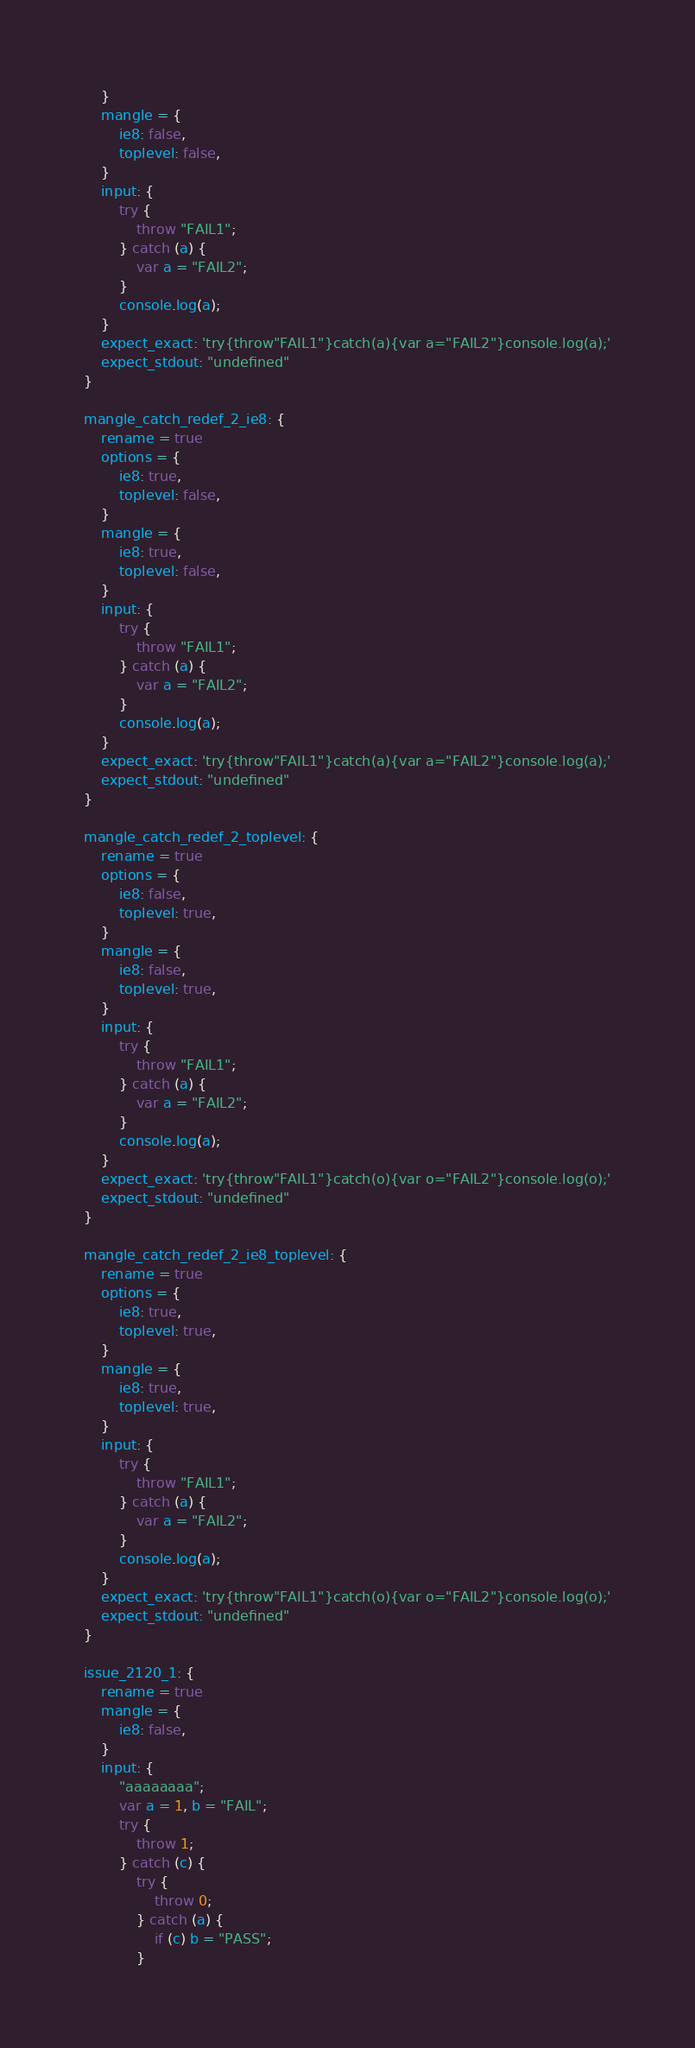Convert code to text. <code><loc_0><loc_0><loc_500><loc_500><_JavaScript_>    }
    mangle = {
        ie8: false,
        toplevel: false,
    }
    input: {
        try {
            throw "FAIL1";
        } catch (a) {
            var a = "FAIL2";
        }
        console.log(a);
    }
    expect_exact: 'try{throw"FAIL1"}catch(a){var a="FAIL2"}console.log(a);'
    expect_stdout: "undefined"
}

mangle_catch_redef_2_ie8: {
    rename = true
    options = {
        ie8: true,
        toplevel: false,
    }
    mangle = {
        ie8: true,
        toplevel: false,
    }
    input: {
        try {
            throw "FAIL1";
        } catch (a) {
            var a = "FAIL2";
        }
        console.log(a);
    }
    expect_exact: 'try{throw"FAIL1"}catch(a){var a="FAIL2"}console.log(a);'
    expect_stdout: "undefined"
}

mangle_catch_redef_2_toplevel: {
    rename = true
    options = {
        ie8: false,
        toplevel: true,
    }
    mangle = {
        ie8: false,
        toplevel: true,
    }
    input: {
        try {
            throw "FAIL1";
        } catch (a) {
            var a = "FAIL2";
        }
        console.log(a);
    }
    expect_exact: 'try{throw"FAIL1"}catch(o){var o="FAIL2"}console.log(o);'
    expect_stdout: "undefined"
}

mangle_catch_redef_2_ie8_toplevel: {
    rename = true
    options = {
        ie8: true,
        toplevel: true,
    }
    mangle = {
        ie8: true,
        toplevel: true,
    }
    input: {
        try {
            throw "FAIL1";
        } catch (a) {
            var a = "FAIL2";
        }
        console.log(a);
    }
    expect_exact: 'try{throw"FAIL1"}catch(o){var o="FAIL2"}console.log(o);'
    expect_stdout: "undefined"
}

issue_2120_1: {
    rename = true
    mangle = {
        ie8: false,
    }
    input: {
        "aaaaaaaa";
        var a = 1, b = "FAIL";
        try {
            throw 1;
        } catch (c) {
            try {
                throw 0;
            } catch (a) {
                if (c) b = "PASS";
            }</code> 